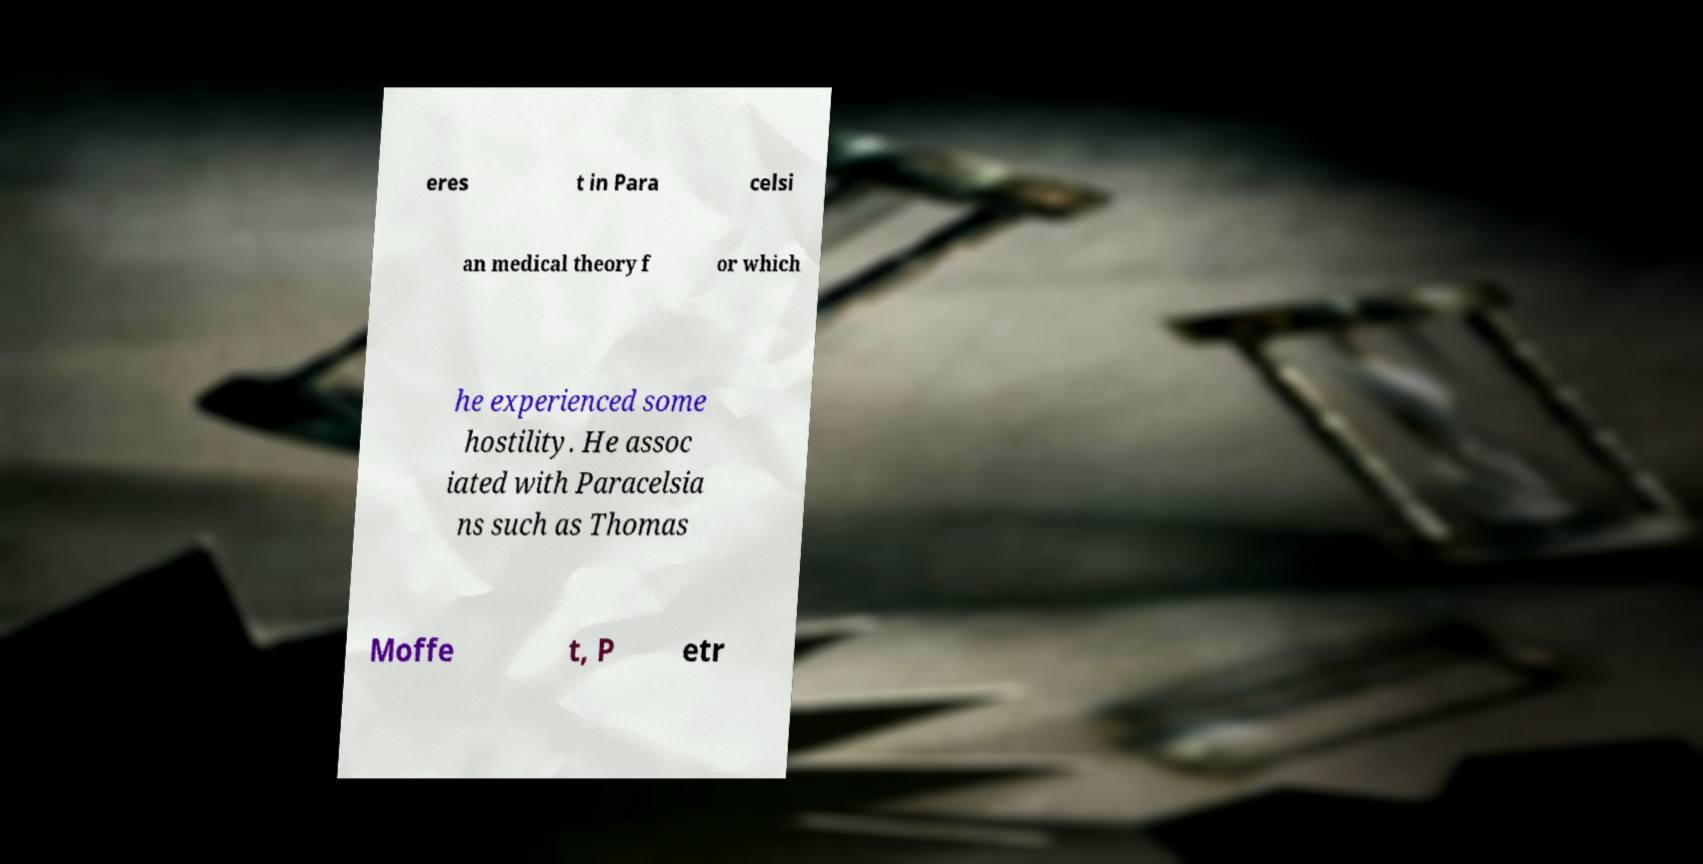Can you read and provide the text displayed in the image?This photo seems to have some interesting text. Can you extract and type it out for me? eres t in Para celsi an medical theory f or which he experienced some hostility. He assoc iated with Paracelsia ns such as Thomas Moffe t, P etr 